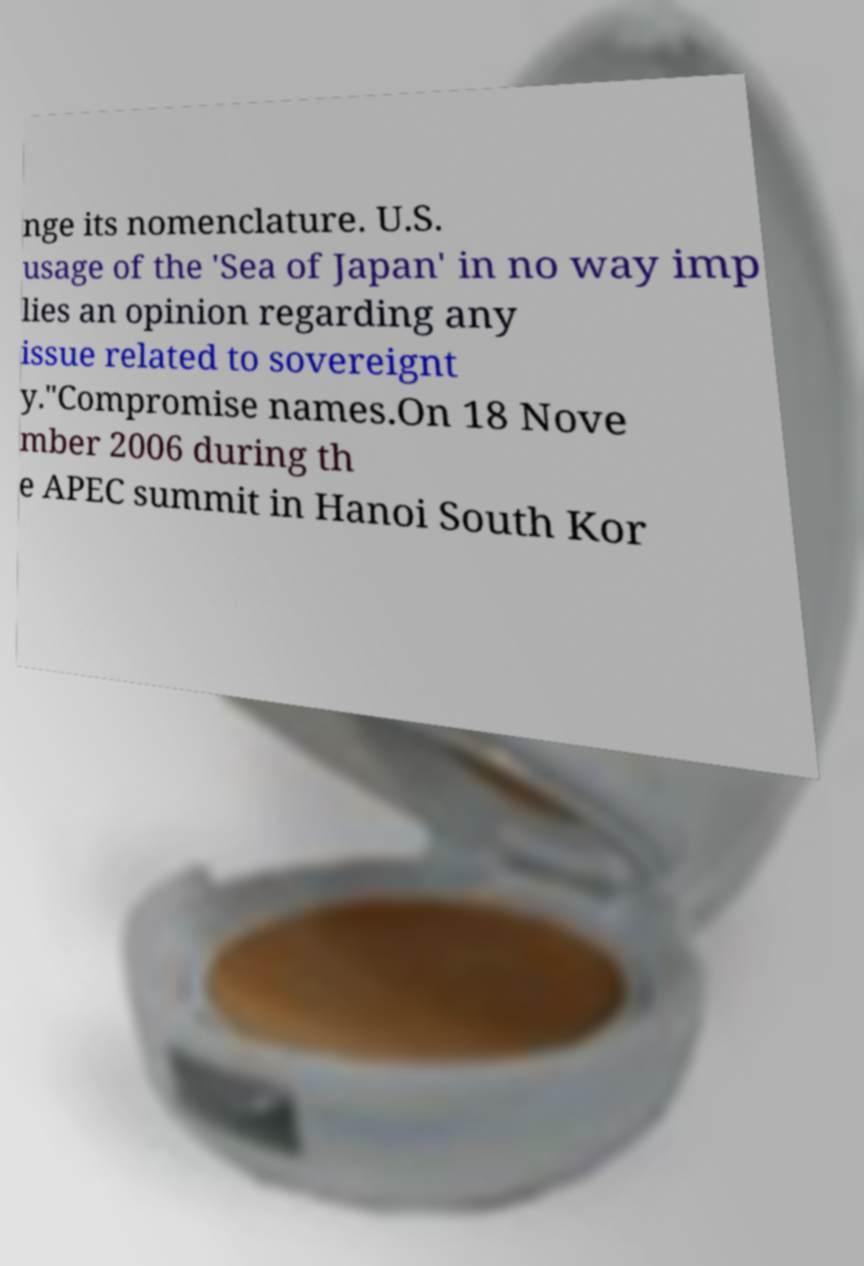What messages or text are displayed in this image? I need them in a readable, typed format. nge its nomenclature. U.S. usage of the 'Sea of Japan' in no way imp lies an opinion regarding any issue related to sovereignt y."Compromise names.On 18 Nove mber 2006 during th e APEC summit in Hanoi South Kor 